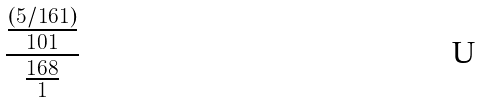Convert formula to latex. <formula><loc_0><loc_0><loc_500><loc_500>\frac { \frac { ( 5 / 1 6 1 ) } { 1 0 1 } } { \frac { 1 6 8 } { 1 } }</formula> 